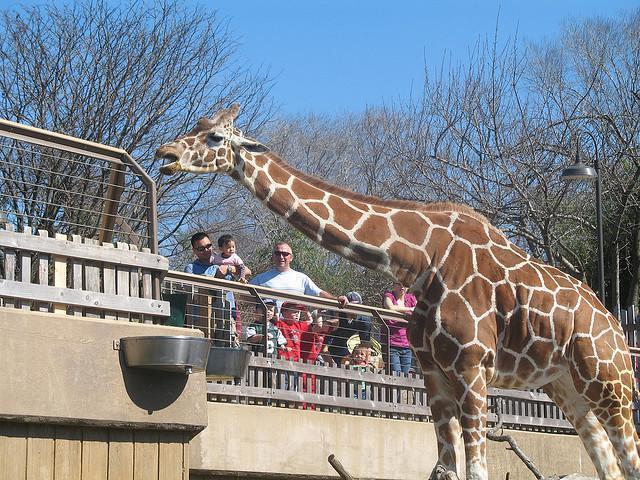How many children are in this image?
Give a very brief answer. 4. 